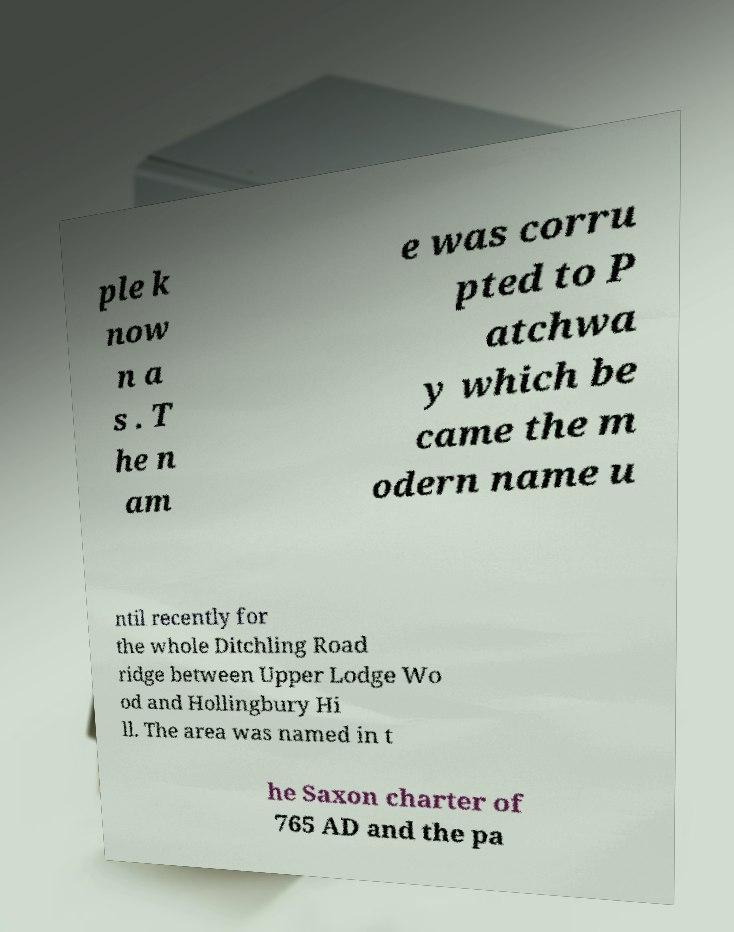Please read and relay the text visible in this image. What does it say? ple k now n a s . T he n am e was corru pted to P atchwa y which be came the m odern name u ntil recently for the whole Ditchling Road ridge between Upper Lodge Wo od and Hollingbury Hi ll. The area was named in t he Saxon charter of 765 AD and the pa 